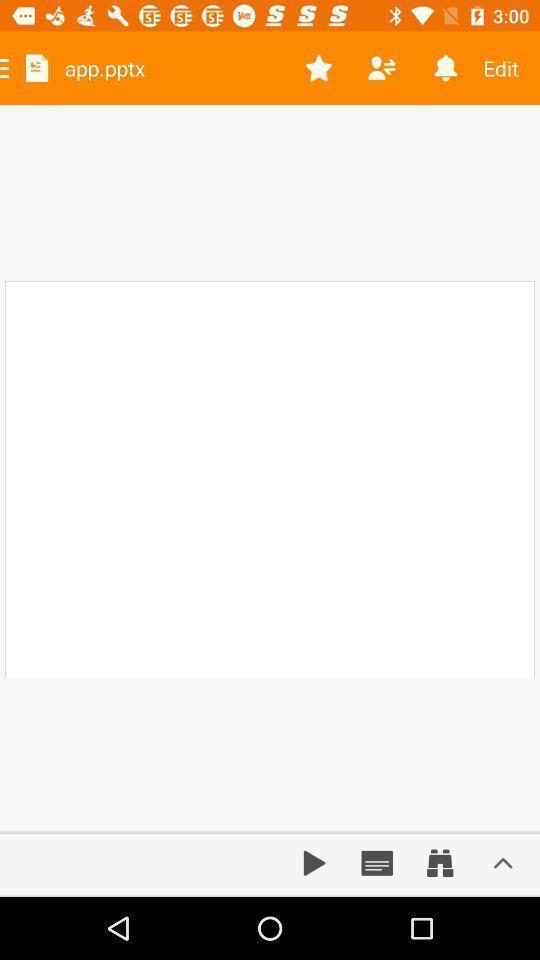Provide a detailed account of this screenshot. Page showing different options. 